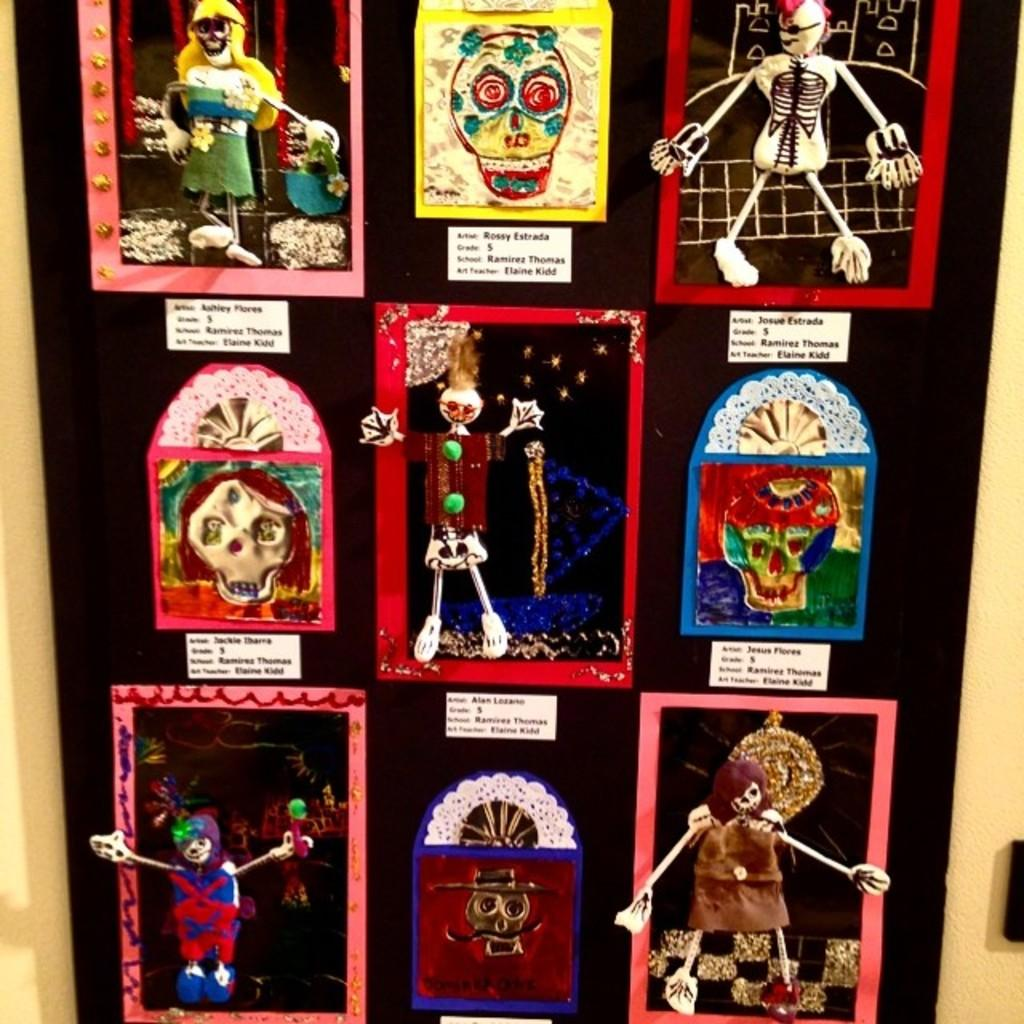What type of objects can be seen in the image? There are dolls in the image. What else can be seen in the image besides the dolls? There are pictures and text visible in the image. What color is the yard in the image? There is no yard present in the image; it features dolls, pictures, and text. 